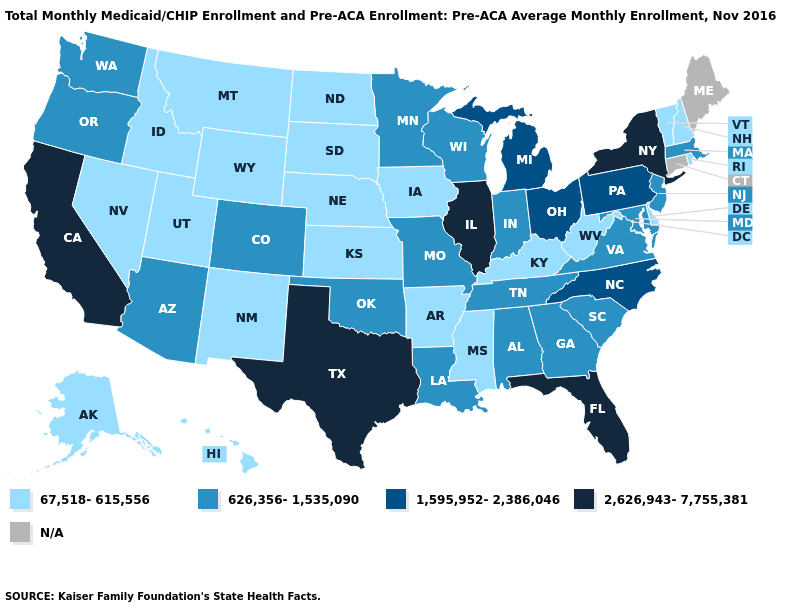Name the states that have a value in the range 1,595,952-2,386,046?
Answer briefly. Michigan, North Carolina, Ohio, Pennsylvania. Among the states that border Vermont , does New Hampshire have the lowest value?
Answer briefly. Yes. Which states have the lowest value in the USA?
Be succinct. Alaska, Arkansas, Delaware, Hawaii, Idaho, Iowa, Kansas, Kentucky, Mississippi, Montana, Nebraska, Nevada, New Hampshire, New Mexico, North Dakota, Rhode Island, South Dakota, Utah, Vermont, West Virginia, Wyoming. What is the value of Alabama?
Quick response, please. 626,356-1,535,090. Among the states that border Alabama , does Florida have the highest value?
Be succinct. Yes. Does the map have missing data?
Concise answer only. Yes. What is the value of Utah?
Quick response, please. 67,518-615,556. What is the value of Pennsylvania?
Concise answer only. 1,595,952-2,386,046. Among the states that border Texas , does Oklahoma have the lowest value?
Answer briefly. No. Which states hav the highest value in the MidWest?
Keep it brief. Illinois. What is the highest value in states that border Arizona?
Write a very short answer. 2,626,943-7,755,381. Which states have the highest value in the USA?
Keep it brief. California, Florida, Illinois, New York, Texas. How many symbols are there in the legend?
Short answer required. 5. Name the states that have a value in the range 626,356-1,535,090?
Answer briefly. Alabama, Arizona, Colorado, Georgia, Indiana, Louisiana, Maryland, Massachusetts, Minnesota, Missouri, New Jersey, Oklahoma, Oregon, South Carolina, Tennessee, Virginia, Washington, Wisconsin. Among the states that border California , which have the highest value?
Write a very short answer. Arizona, Oregon. 